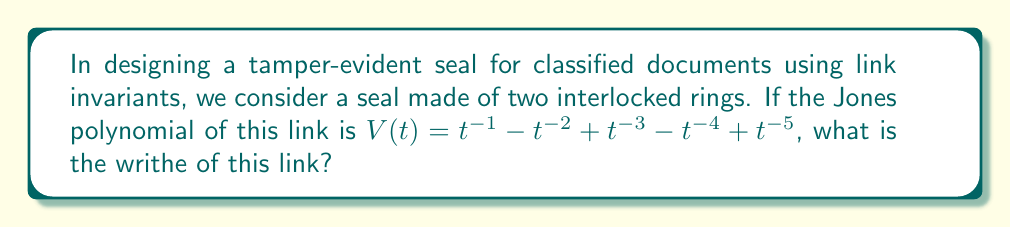Solve this math problem. To find the writhe of the link from its Jones polynomial, we can follow these steps:

1) Recall that for an oriented link L, the Jones polynomial $V_L(t)$ is related to the Kauffman bracket polynomial $\langle L \rangle$ by:

   $V_L(t) = (-A^{-3})^{w(L)} \langle L \rangle |_{A = t^{-1/4}}$

   where $w(L)$ is the writhe of the link.

2) In our case, $V(t) = t^{-1} - t^{-2} + t^{-3} - t^{-4} + t^{-5}$

3) The highest degree term in $V(t)$ is $t^{-1}$. Let's call this degree $m$. So $m = -1$.

4) For alternating links (which we assume this is, given its simple description), the writhe $w(L)$ is related to $m$ by:

   $w(L) = -3m - 3$

5) Substituting $m = -1$:

   $w(L) = -3(-1) - 3 = 3 - 3 = 0$

Therefore, the writhe of this link is 0.
Answer: 0 